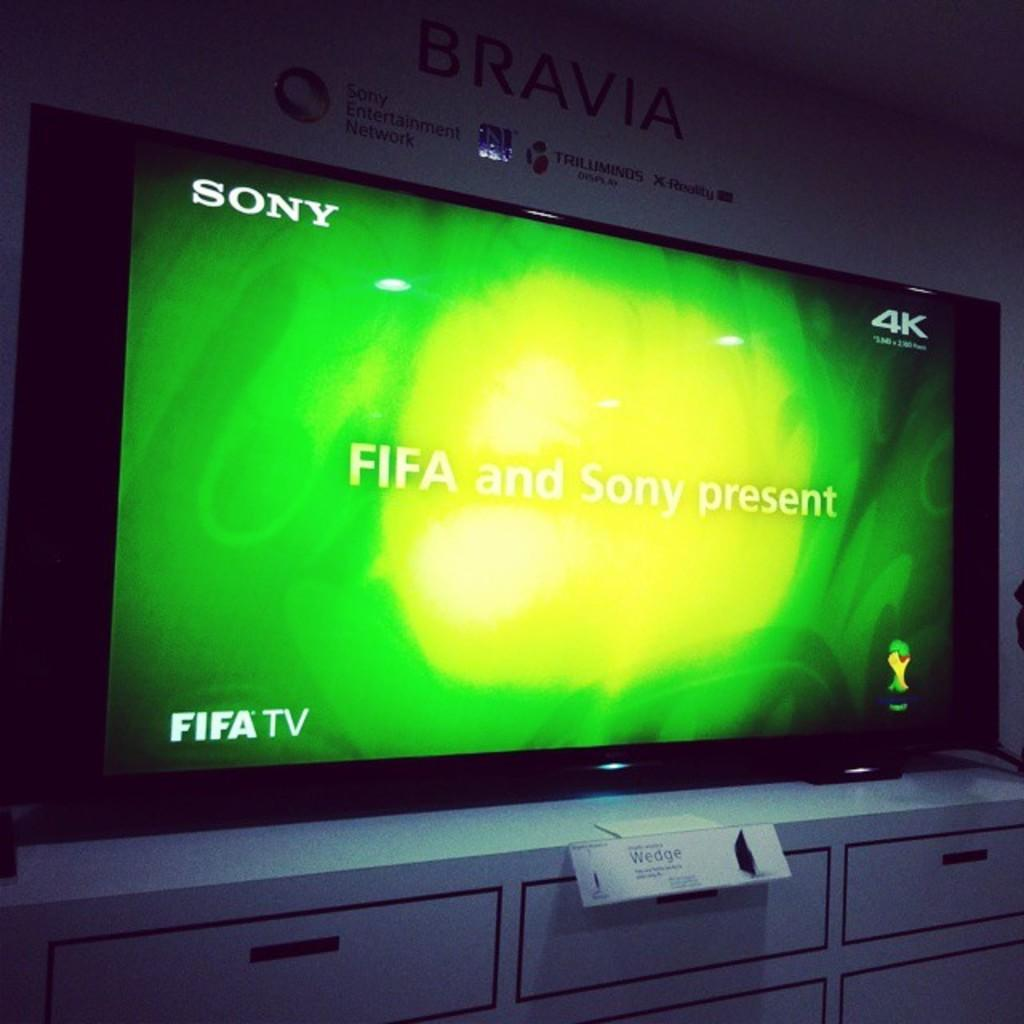<image>
Give a short and clear explanation of the subsequent image. A large flat screen TV sits on top of a dresser and it's tuned to FIFA TV. 